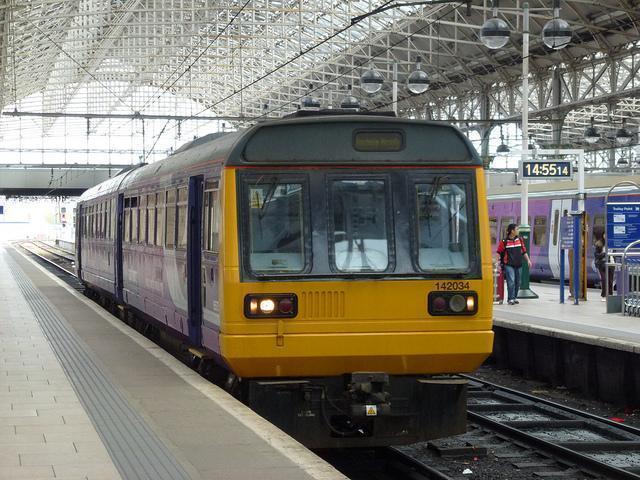What session of the day is shown in the photo?
Make your selection from the four choices given to correctly answer the question.
Options: Dawn, afternoon, morning, evening. Afternoon. 